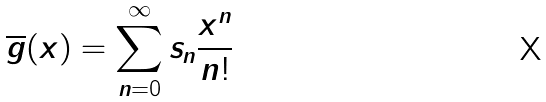Convert formula to latex. <formula><loc_0><loc_0><loc_500><loc_500>\overline { g } ( x ) = \sum _ { n = 0 } ^ { \infty } s _ { n } \frac { x ^ { n } } { n ! }</formula> 